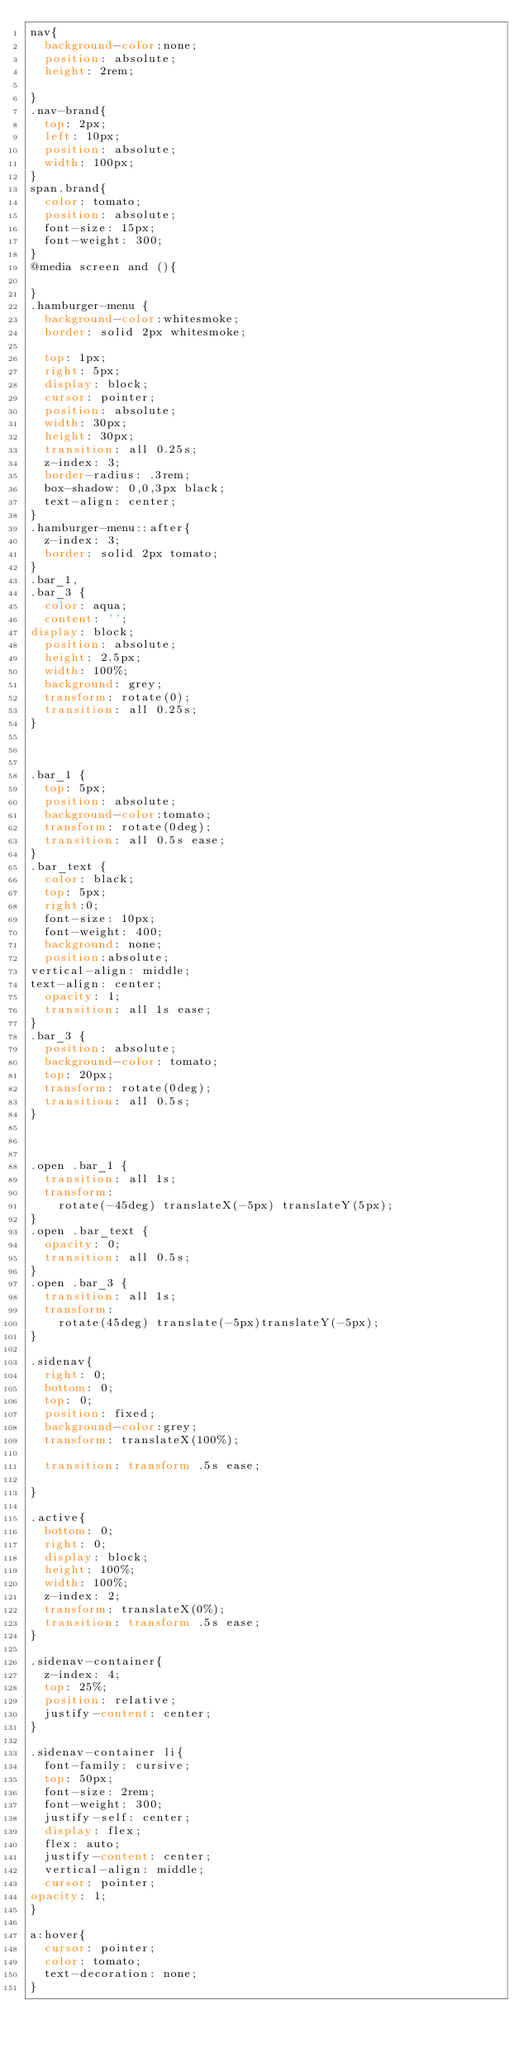Convert code to text. <code><loc_0><loc_0><loc_500><loc_500><_CSS_>nav{
  background-color:none;
  position: absolute;
  height: 2rem;

}
.nav-brand{
  top: 2px;
  left: 10px;
  position: absolute;
  width: 100px;
}
span.brand{
  color: tomato;
  position: absolute;
  font-size: 15px;
  font-weight: 300;
}
@media screen and (){

}
.hamburger-menu {
  background-color:whitesmoke;
  border: solid 2px whitesmoke;

  top: 1px;
  right: 5px;
  display: block;
  cursor: pointer;
  position: absolute;
  width: 30px;
  height: 30px;
  transition: all 0.25s;
  z-index: 3;
  border-radius: .3rem;
  box-shadow: 0,0,3px black;
  text-align: center;
}
.hamburger-menu::after{
  z-index: 3;
  border: solid 2px tomato;
}
.bar_1,
.bar_3 {
  color: aqua;
  content: '';
display: block;
  position: absolute;
  height: 2.5px;
  width: 100%;
  background: grey;
  transform: rotate(0);
  transition: all 0.25s;
}



.bar_1 {
  top: 5px;
  position: absolute;
  background-color:tomato;
  transform: rotate(0deg);
  transition: all 0.5s ease;
}
.bar_text {
  color: black;
  top: 5px;
  right:0;
  font-size: 10px;
  font-weight: 400;
  background: none;
  position:absolute;
vertical-align: middle;
text-align: center;
  opacity: 1;
  transition: all 1s ease;
}
.bar_3 {
  position: absolute;
  background-color: tomato;
  top: 20px;
  transform: rotate(0deg);
  transition: all 0.5s;
}



.open .bar_1 {
  transition: all 1s;
  transform: 
    rotate(-45deg) translateX(-5px) translateY(5px);
}
.open .bar_text {
  opacity: 0;
  transition: all 0.5s;
}
.open .bar_3 {
  transition: all 1s;
  transform: 
    rotate(45deg) translate(-5px)translateY(-5px);
} 

.sidenav{
  right: 0;
  bottom: 0;
  top: 0;
  position: fixed;
  background-color:grey;
	transform: translateX(100%);

	transition: transform .5s ease;
 
}

.active{
  bottom: 0;
  right: 0;
  display: block;
  height: 100%;
  width: 100%;
  z-index: 2;
  transform: translateX(0%);
  transition: transform .5s ease;
}

.sidenav-container{
  z-index: 4;
  top: 25%;
  position: relative;
  justify-content: center;
}

.sidenav-container li{
  font-family: cursive;
  top: 50px;
  font-size: 2rem;
  font-weight: 300;
  justify-self: center;
  display: flex;
  flex: auto;
  justify-content: center;
  vertical-align: middle;
  cursor: pointer;
opacity: 1;
}

a:hover{
  cursor: pointer;
  color: tomato;
  text-decoration: none;
}
</code> 